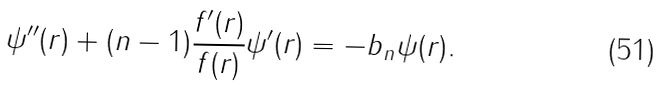Convert formula to latex. <formula><loc_0><loc_0><loc_500><loc_500>\psi ^ { \prime \prime } ( r ) + ( n - 1 ) \frac { f ^ { \prime } ( r ) } { f ( r ) } \psi ^ { \prime } ( r ) = - b _ { n } \psi ( r ) .</formula> 